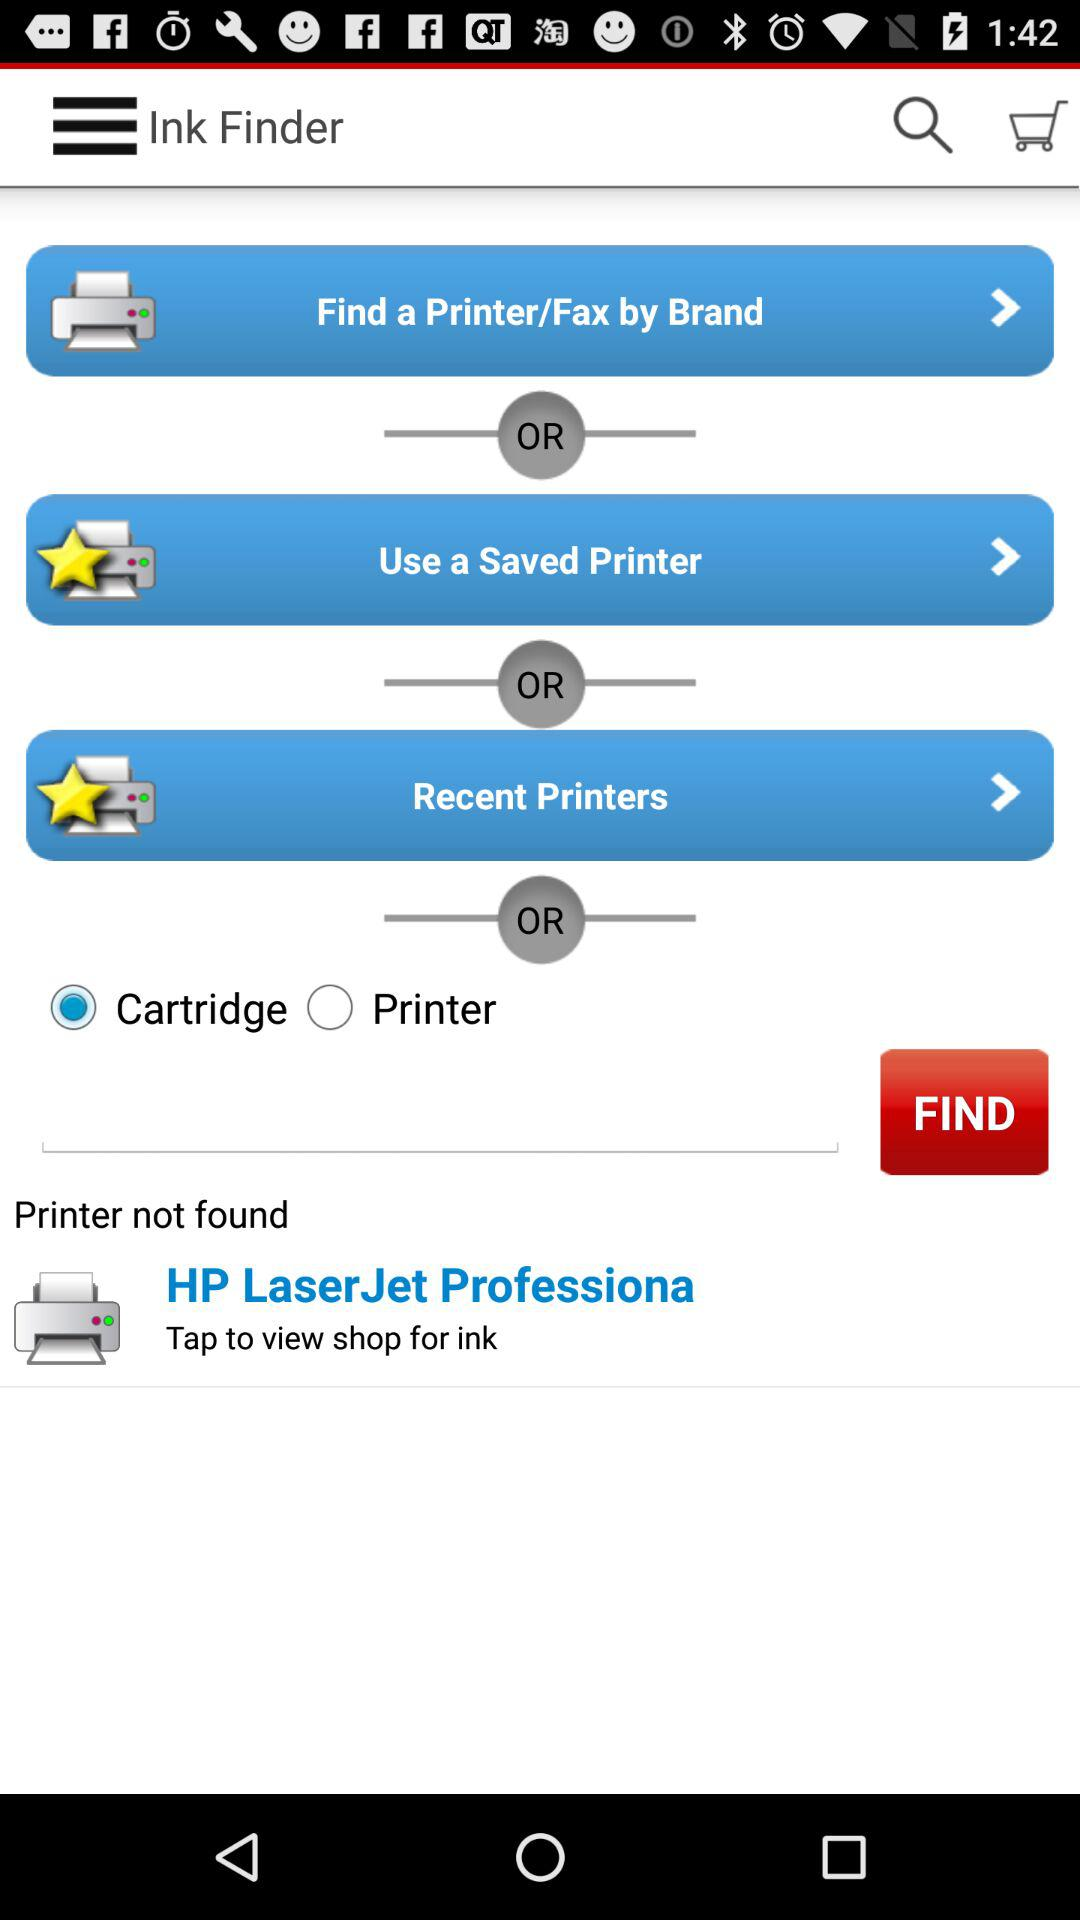What printer isn't available? The printer that isn't available is the HP LaserJet Professiona. 